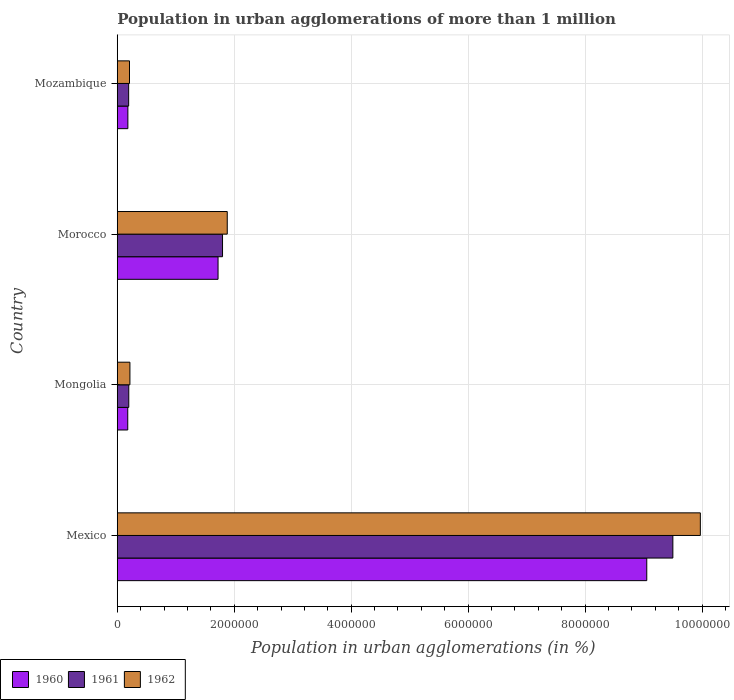How many different coloured bars are there?
Provide a short and direct response. 3. Are the number of bars per tick equal to the number of legend labels?
Provide a short and direct response. Yes. What is the label of the 3rd group of bars from the top?
Ensure brevity in your answer.  Mongolia. What is the population in urban agglomerations in 1961 in Mexico?
Your answer should be compact. 9.50e+06. Across all countries, what is the maximum population in urban agglomerations in 1960?
Provide a succinct answer. 9.05e+06. Across all countries, what is the minimum population in urban agglomerations in 1960?
Offer a terse response. 1.79e+05. In which country was the population in urban agglomerations in 1961 minimum?
Offer a very short reply. Mozambique. What is the total population in urban agglomerations in 1962 in the graph?
Ensure brevity in your answer.  1.23e+07. What is the difference between the population in urban agglomerations in 1962 in Morocco and that in Mozambique?
Keep it short and to the point. 1.67e+06. What is the difference between the population in urban agglomerations in 1961 in Morocco and the population in urban agglomerations in 1960 in Mozambique?
Keep it short and to the point. 1.62e+06. What is the average population in urban agglomerations in 1961 per country?
Keep it short and to the point. 2.92e+06. What is the difference between the population in urban agglomerations in 1962 and population in urban agglomerations in 1960 in Mozambique?
Your answer should be very brief. 2.78e+04. In how many countries, is the population in urban agglomerations in 1961 greater than 10000000 %?
Offer a very short reply. 0. What is the ratio of the population in urban agglomerations in 1962 in Mexico to that in Mongolia?
Keep it short and to the point. 46.15. Is the population in urban agglomerations in 1962 in Mongolia less than that in Morocco?
Your answer should be compact. Yes. Is the difference between the population in urban agglomerations in 1962 in Mexico and Mozambique greater than the difference between the population in urban agglomerations in 1960 in Mexico and Mozambique?
Your answer should be very brief. Yes. What is the difference between the highest and the second highest population in urban agglomerations in 1961?
Ensure brevity in your answer.  7.70e+06. What is the difference between the highest and the lowest population in urban agglomerations in 1962?
Your answer should be very brief. 9.76e+06. Is the sum of the population in urban agglomerations in 1961 in Morocco and Mozambique greater than the maximum population in urban agglomerations in 1962 across all countries?
Give a very brief answer. No. How many countries are there in the graph?
Your answer should be very brief. 4. Does the graph contain any zero values?
Make the answer very short. No. Where does the legend appear in the graph?
Your answer should be compact. Bottom left. How are the legend labels stacked?
Keep it short and to the point. Horizontal. What is the title of the graph?
Ensure brevity in your answer.  Population in urban agglomerations of more than 1 million. What is the label or title of the X-axis?
Your answer should be very brief. Population in urban agglomerations (in %). What is the label or title of the Y-axis?
Offer a very short reply. Country. What is the Population in urban agglomerations (in %) in 1960 in Mexico?
Keep it short and to the point. 9.05e+06. What is the Population in urban agglomerations (in %) in 1961 in Mexico?
Ensure brevity in your answer.  9.50e+06. What is the Population in urban agglomerations (in %) of 1962 in Mexico?
Keep it short and to the point. 9.97e+06. What is the Population in urban agglomerations (in %) in 1960 in Mongolia?
Your answer should be very brief. 1.79e+05. What is the Population in urban agglomerations (in %) of 1961 in Mongolia?
Keep it short and to the point. 1.97e+05. What is the Population in urban agglomerations (in %) in 1962 in Mongolia?
Offer a very short reply. 2.16e+05. What is the Population in urban agglomerations (in %) in 1960 in Morocco?
Ensure brevity in your answer.  1.72e+06. What is the Population in urban agglomerations (in %) in 1961 in Morocco?
Provide a short and direct response. 1.80e+06. What is the Population in urban agglomerations (in %) of 1962 in Morocco?
Make the answer very short. 1.88e+06. What is the Population in urban agglomerations (in %) in 1960 in Mozambique?
Give a very brief answer. 1.81e+05. What is the Population in urban agglomerations (in %) in 1961 in Mozambique?
Your answer should be very brief. 1.95e+05. What is the Population in urban agglomerations (in %) in 1962 in Mozambique?
Give a very brief answer. 2.09e+05. Across all countries, what is the maximum Population in urban agglomerations (in %) of 1960?
Provide a short and direct response. 9.05e+06. Across all countries, what is the maximum Population in urban agglomerations (in %) in 1961?
Your answer should be compact. 9.50e+06. Across all countries, what is the maximum Population in urban agglomerations (in %) in 1962?
Offer a terse response. 9.97e+06. Across all countries, what is the minimum Population in urban agglomerations (in %) in 1960?
Give a very brief answer. 1.79e+05. Across all countries, what is the minimum Population in urban agglomerations (in %) in 1961?
Keep it short and to the point. 1.95e+05. Across all countries, what is the minimum Population in urban agglomerations (in %) in 1962?
Make the answer very short. 2.09e+05. What is the total Population in urban agglomerations (in %) of 1960 in the graph?
Provide a succinct answer. 1.11e+07. What is the total Population in urban agglomerations (in %) of 1961 in the graph?
Provide a short and direct response. 1.17e+07. What is the total Population in urban agglomerations (in %) of 1962 in the graph?
Ensure brevity in your answer.  1.23e+07. What is the difference between the Population in urban agglomerations (in %) in 1960 in Mexico and that in Mongolia?
Provide a succinct answer. 8.88e+06. What is the difference between the Population in urban agglomerations (in %) of 1961 in Mexico and that in Mongolia?
Offer a very short reply. 9.30e+06. What is the difference between the Population in urban agglomerations (in %) in 1962 in Mexico and that in Mongolia?
Keep it short and to the point. 9.75e+06. What is the difference between the Population in urban agglomerations (in %) of 1960 in Mexico and that in Morocco?
Ensure brevity in your answer.  7.33e+06. What is the difference between the Population in urban agglomerations (in %) of 1961 in Mexico and that in Morocco?
Offer a very short reply. 7.70e+06. What is the difference between the Population in urban agglomerations (in %) of 1962 in Mexico and that in Morocco?
Ensure brevity in your answer.  8.09e+06. What is the difference between the Population in urban agglomerations (in %) in 1960 in Mexico and that in Mozambique?
Offer a very short reply. 8.87e+06. What is the difference between the Population in urban agglomerations (in %) in 1961 in Mexico and that in Mozambique?
Provide a short and direct response. 9.31e+06. What is the difference between the Population in urban agglomerations (in %) in 1962 in Mexico and that in Mozambique?
Offer a terse response. 9.76e+06. What is the difference between the Population in urban agglomerations (in %) of 1960 in Mongolia and that in Morocco?
Your answer should be very brief. -1.54e+06. What is the difference between the Population in urban agglomerations (in %) in 1961 in Mongolia and that in Morocco?
Your response must be concise. -1.60e+06. What is the difference between the Population in urban agglomerations (in %) of 1962 in Mongolia and that in Morocco?
Provide a succinct answer. -1.66e+06. What is the difference between the Population in urban agglomerations (in %) in 1960 in Mongolia and that in Mozambique?
Your response must be concise. -2160. What is the difference between the Population in urban agglomerations (in %) in 1961 in Mongolia and that in Mozambique?
Offer a very short reply. 2138. What is the difference between the Population in urban agglomerations (in %) of 1962 in Mongolia and that in Mozambique?
Your response must be concise. 7029. What is the difference between the Population in urban agglomerations (in %) of 1960 in Morocco and that in Mozambique?
Keep it short and to the point. 1.54e+06. What is the difference between the Population in urban agglomerations (in %) of 1961 in Morocco and that in Mozambique?
Give a very brief answer. 1.61e+06. What is the difference between the Population in urban agglomerations (in %) in 1962 in Morocco and that in Mozambique?
Give a very brief answer. 1.67e+06. What is the difference between the Population in urban agglomerations (in %) in 1960 in Mexico and the Population in urban agglomerations (in %) in 1961 in Mongolia?
Keep it short and to the point. 8.86e+06. What is the difference between the Population in urban agglomerations (in %) of 1960 in Mexico and the Population in urban agglomerations (in %) of 1962 in Mongolia?
Offer a terse response. 8.84e+06. What is the difference between the Population in urban agglomerations (in %) of 1961 in Mexico and the Population in urban agglomerations (in %) of 1962 in Mongolia?
Offer a terse response. 9.28e+06. What is the difference between the Population in urban agglomerations (in %) of 1960 in Mexico and the Population in urban agglomerations (in %) of 1961 in Morocco?
Offer a very short reply. 7.25e+06. What is the difference between the Population in urban agglomerations (in %) of 1960 in Mexico and the Population in urban agglomerations (in %) of 1962 in Morocco?
Offer a very short reply. 7.17e+06. What is the difference between the Population in urban agglomerations (in %) of 1961 in Mexico and the Population in urban agglomerations (in %) of 1962 in Morocco?
Ensure brevity in your answer.  7.62e+06. What is the difference between the Population in urban agglomerations (in %) in 1960 in Mexico and the Population in urban agglomerations (in %) in 1961 in Mozambique?
Your answer should be compact. 8.86e+06. What is the difference between the Population in urban agglomerations (in %) in 1960 in Mexico and the Population in urban agglomerations (in %) in 1962 in Mozambique?
Ensure brevity in your answer.  8.85e+06. What is the difference between the Population in urban agglomerations (in %) in 1961 in Mexico and the Population in urban agglomerations (in %) in 1962 in Mozambique?
Your response must be concise. 9.29e+06. What is the difference between the Population in urban agglomerations (in %) in 1960 in Mongolia and the Population in urban agglomerations (in %) in 1961 in Morocco?
Offer a very short reply. -1.62e+06. What is the difference between the Population in urban agglomerations (in %) in 1960 in Mongolia and the Population in urban agglomerations (in %) in 1962 in Morocco?
Your answer should be very brief. -1.70e+06. What is the difference between the Population in urban agglomerations (in %) of 1961 in Mongolia and the Population in urban agglomerations (in %) of 1962 in Morocco?
Your answer should be compact. -1.68e+06. What is the difference between the Population in urban agglomerations (in %) in 1960 in Mongolia and the Population in urban agglomerations (in %) in 1961 in Mozambique?
Keep it short and to the point. -1.55e+04. What is the difference between the Population in urban agglomerations (in %) of 1960 in Mongolia and the Population in urban agglomerations (in %) of 1962 in Mozambique?
Provide a short and direct response. -3.00e+04. What is the difference between the Population in urban agglomerations (in %) in 1961 in Mongolia and the Population in urban agglomerations (in %) in 1962 in Mozambique?
Offer a terse response. -1.24e+04. What is the difference between the Population in urban agglomerations (in %) of 1960 in Morocco and the Population in urban agglomerations (in %) of 1961 in Mozambique?
Your answer should be compact. 1.53e+06. What is the difference between the Population in urban agglomerations (in %) of 1960 in Morocco and the Population in urban agglomerations (in %) of 1962 in Mozambique?
Provide a succinct answer. 1.51e+06. What is the difference between the Population in urban agglomerations (in %) in 1961 in Morocco and the Population in urban agglomerations (in %) in 1962 in Mozambique?
Offer a terse response. 1.59e+06. What is the average Population in urban agglomerations (in %) in 1960 per country?
Give a very brief answer. 2.78e+06. What is the average Population in urban agglomerations (in %) in 1961 per country?
Offer a terse response. 2.92e+06. What is the average Population in urban agglomerations (in %) in 1962 per country?
Make the answer very short. 3.07e+06. What is the difference between the Population in urban agglomerations (in %) of 1960 and Population in urban agglomerations (in %) of 1961 in Mexico?
Offer a terse response. -4.46e+05. What is the difference between the Population in urban agglomerations (in %) of 1960 and Population in urban agglomerations (in %) of 1962 in Mexico?
Offer a terse response. -9.16e+05. What is the difference between the Population in urban agglomerations (in %) in 1961 and Population in urban agglomerations (in %) in 1962 in Mexico?
Offer a very short reply. -4.70e+05. What is the difference between the Population in urban agglomerations (in %) of 1960 and Population in urban agglomerations (in %) of 1961 in Mongolia?
Offer a terse response. -1.76e+04. What is the difference between the Population in urban agglomerations (in %) in 1960 and Population in urban agglomerations (in %) in 1962 in Mongolia?
Provide a succinct answer. -3.70e+04. What is the difference between the Population in urban agglomerations (in %) in 1961 and Population in urban agglomerations (in %) in 1962 in Mongolia?
Your answer should be compact. -1.94e+04. What is the difference between the Population in urban agglomerations (in %) of 1960 and Population in urban agglomerations (in %) of 1961 in Morocco?
Give a very brief answer. -7.66e+04. What is the difference between the Population in urban agglomerations (in %) of 1960 and Population in urban agglomerations (in %) of 1962 in Morocco?
Give a very brief answer. -1.57e+05. What is the difference between the Population in urban agglomerations (in %) in 1961 and Population in urban agglomerations (in %) in 1962 in Morocco?
Ensure brevity in your answer.  -8.05e+04. What is the difference between the Population in urban agglomerations (in %) in 1960 and Population in urban agglomerations (in %) in 1961 in Mozambique?
Offer a terse response. -1.33e+04. What is the difference between the Population in urban agglomerations (in %) of 1960 and Population in urban agglomerations (in %) of 1962 in Mozambique?
Make the answer very short. -2.78e+04. What is the difference between the Population in urban agglomerations (in %) of 1961 and Population in urban agglomerations (in %) of 1962 in Mozambique?
Offer a terse response. -1.45e+04. What is the ratio of the Population in urban agglomerations (in %) in 1960 in Mexico to that in Mongolia?
Your response must be concise. 50.57. What is the ratio of the Population in urban agglomerations (in %) of 1961 in Mexico to that in Mongolia?
Make the answer very short. 48.31. What is the ratio of the Population in urban agglomerations (in %) of 1962 in Mexico to that in Mongolia?
Keep it short and to the point. 46.15. What is the ratio of the Population in urban agglomerations (in %) of 1960 in Mexico to that in Morocco?
Give a very brief answer. 5.25. What is the ratio of the Population in urban agglomerations (in %) in 1961 in Mexico to that in Morocco?
Provide a succinct answer. 5.28. What is the ratio of the Population in urban agglomerations (in %) of 1962 in Mexico to that in Morocco?
Offer a very short reply. 5.3. What is the ratio of the Population in urban agglomerations (in %) in 1960 in Mexico to that in Mozambique?
Your answer should be very brief. 49.96. What is the ratio of the Population in urban agglomerations (in %) of 1961 in Mexico to that in Mozambique?
Your response must be concise. 48.84. What is the ratio of the Population in urban agglomerations (in %) of 1962 in Mexico to that in Mozambique?
Make the answer very short. 47.7. What is the ratio of the Population in urban agglomerations (in %) in 1960 in Mongolia to that in Morocco?
Keep it short and to the point. 0.1. What is the ratio of the Population in urban agglomerations (in %) in 1961 in Mongolia to that in Morocco?
Make the answer very short. 0.11. What is the ratio of the Population in urban agglomerations (in %) in 1962 in Mongolia to that in Morocco?
Your response must be concise. 0.11. What is the ratio of the Population in urban agglomerations (in %) in 1962 in Mongolia to that in Mozambique?
Your answer should be compact. 1.03. What is the ratio of the Population in urban agglomerations (in %) in 1960 in Morocco to that in Mozambique?
Offer a very short reply. 9.51. What is the ratio of the Population in urban agglomerations (in %) of 1961 in Morocco to that in Mozambique?
Your response must be concise. 9.25. What is the ratio of the Population in urban agglomerations (in %) of 1962 in Morocco to that in Mozambique?
Provide a succinct answer. 9. What is the difference between the highest and the second highest Population in urban agglomerations (in %) in 1960?
Offer a terse response. 7.33e+06. What is the difference between the highest and the second highest Population in urban agglomerations (in %) of 1961?
Your answer should be compact. 7.70e+06. What is the difference between the highest and the second highest Population in urban agglomerations (in %) of 1962?
Offer a very short reply. 8.09e+06. What is the difference between the highest and the lowest Population in urban agglomerations (in %) in 1960?
Make the answer very short. 8.88e+06. What is the difference between the highest and the lowest Population in urban agglomerations (in %) in 1961?
Your answer should be very brief. 9.31e+06. What is the difference between the highest and the lowest Population in urban agglomerations (in %) in 1962?
Ensure brevity in your answer.  9.76e+06. 